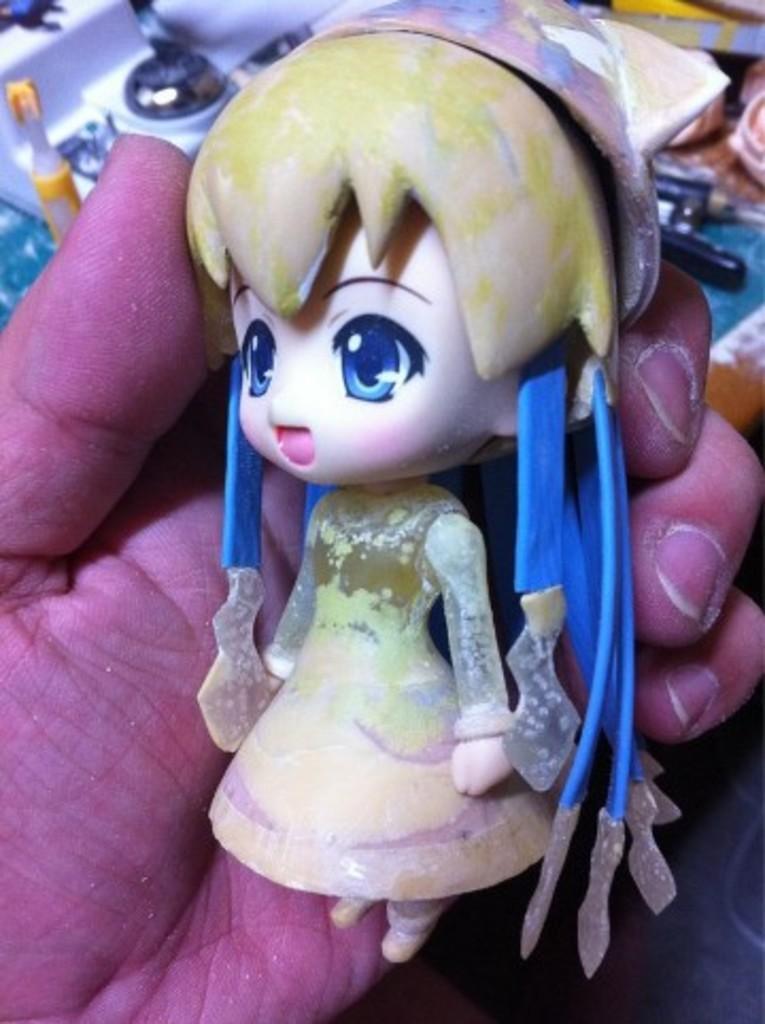In one or two sentences, can you explain what this image depicts? In this picture we can see the person's hand who is holding a doll. On the table we can see the paste, scissor, chocolate, papers, mat and other object. 